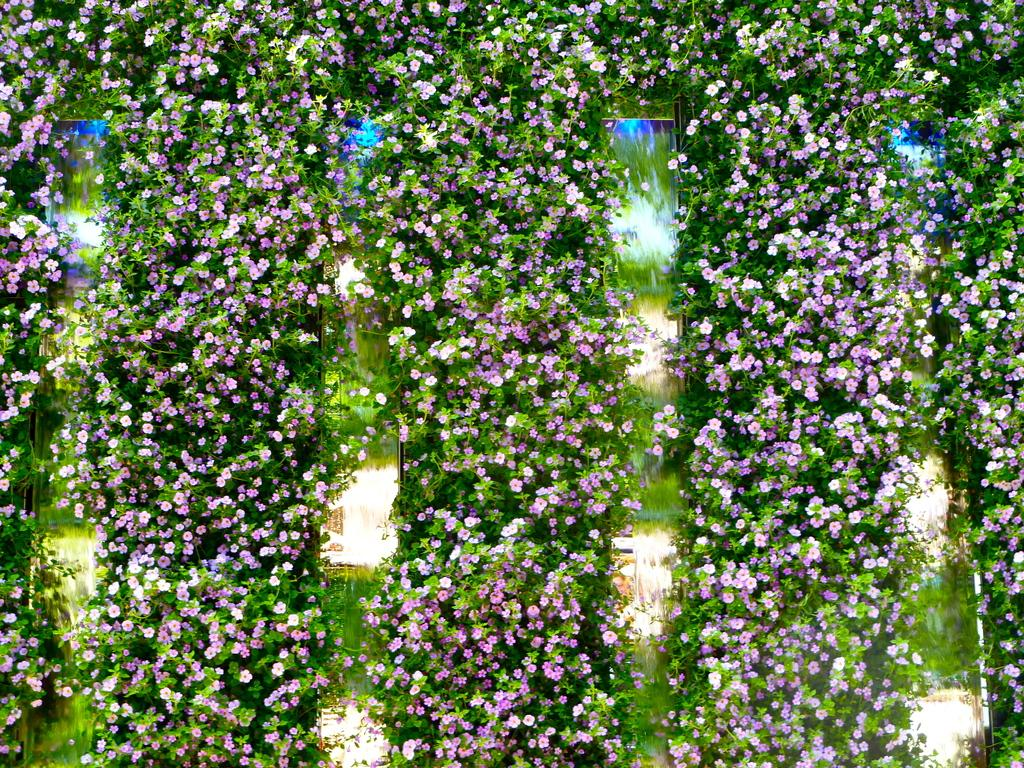What type of plants can be seen in the image? There are many creepers in the image. What do the creepers have that makes them visually appealing? The creepers have beautiful flowers. What colors can be seen in the flowers? The flowers are purple, pink, and white in color. Where is the faucet located in the image? There is no faucet present in the image. How many snakes are slithering among the creepers in the image? There are no snakes present in the image; it features creepers with beautiful flowers. 